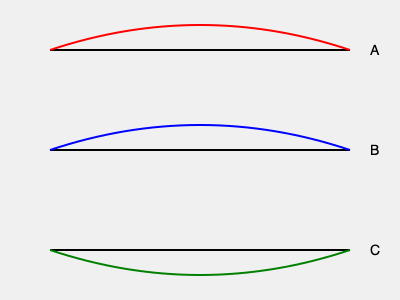Which track layout (A, B, or C) would be most efficient for long-distance running, considering factors like energy conservation and maintaining a consistent pace? To determine the most efficient track layout for long-distance running, we need to consider several factors:

1. Energy conservation: A flatter course requires less energy expenditure over time.
2. Consistent pace: A uniform layout allows runners to maintain a steady rhythm.
3. Physiological impact: Frequent changes in elevation can lead to muscle fatigue.

Analyzing the three layouts:

A. This track has a significant uphill section followed by a downhill. While downhill running can be faster, the uphill portion requires more energy and can disrupt pacing.

B. This layout is the flattest of the three, with only slight elevation changes. It allows for the most consistent pace and energy expenditure throughout the run.

C. Similar to A, but inverted. The downhill start might seem advantageous, but it can lead to early fatigue and difficulty maintaining pace on the uphill section.

For long-distance running, maintaining a steady pace and conserving energy are crucial. Track B provides the best opportunity for both, as it minimizes elevation changes and allows for a more consistent effort throughout the run.

This aligns with the training philosophy of elite Moroccan runners like Mehdi Belhadj, who often emphasize the importance of pacing and efficiency in long-distance events.
Answer: B 